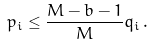Convert formula to latex. <formula><loc_0><loc_0><loc_500><loc_500>p _ { i } \leq \frac { M - b - 1 } { M } q _ { i } \, .</formula> 